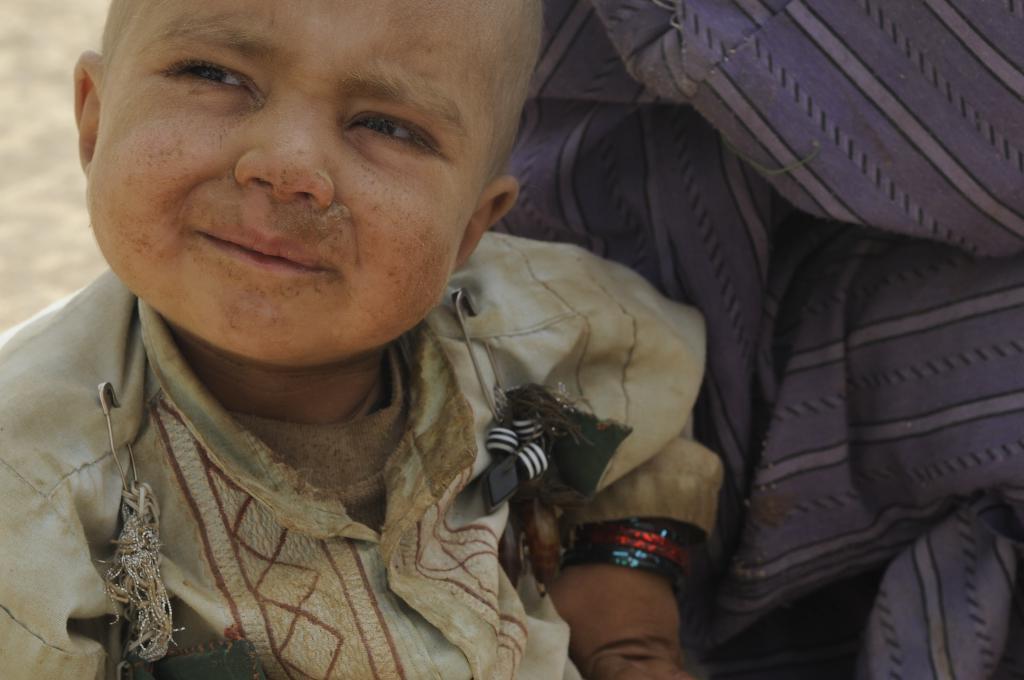How would you summarize this image in a sentence or two? In the image there is a small kid with dusty dress and there is dust on all over him, beside him there is a cloth, there are two safety on the dress of the boy. 